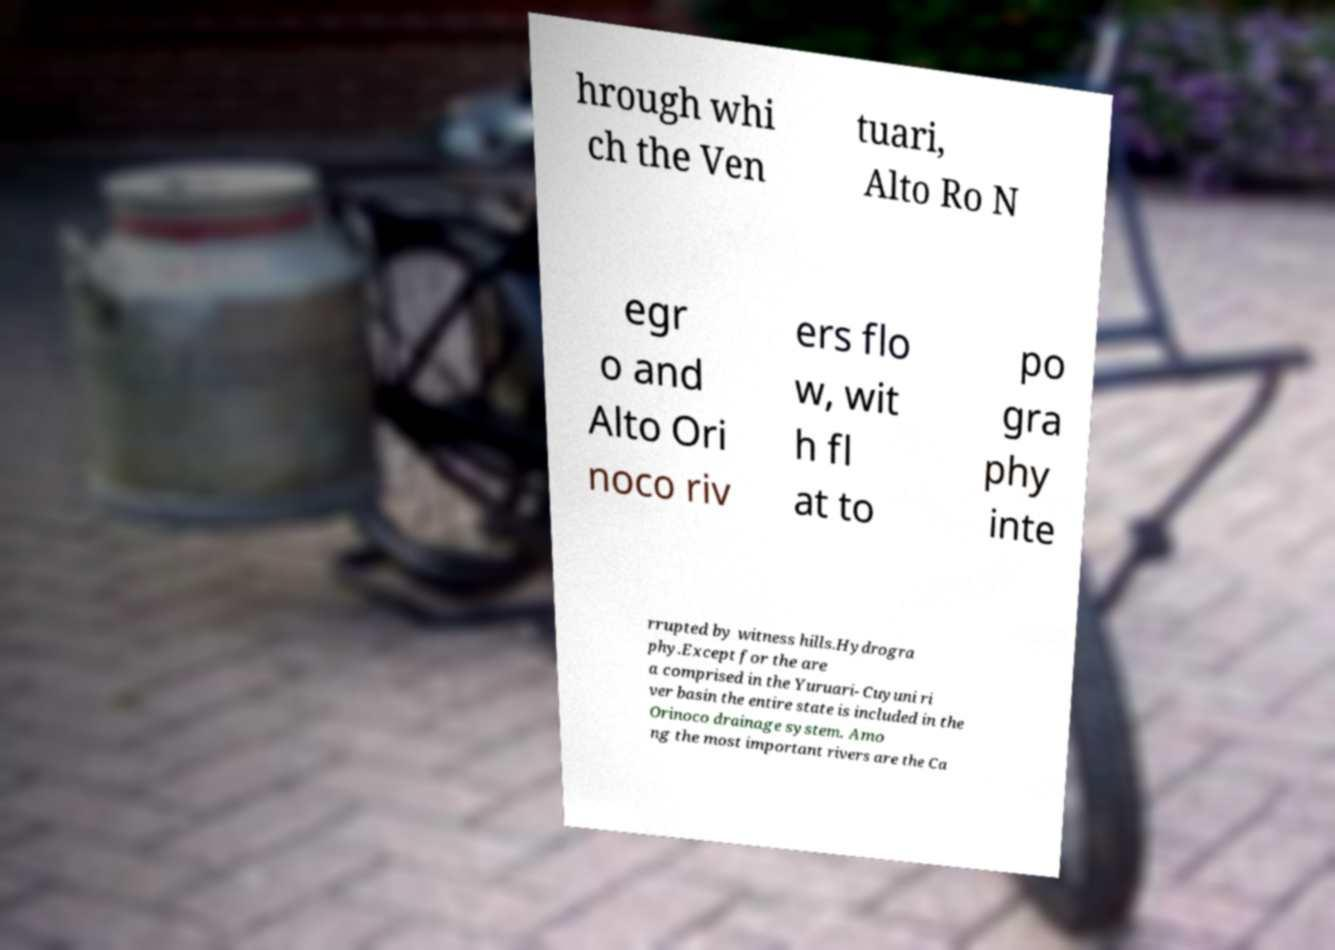I need the written content from this picture converted into text. Can you do that? hrough whi ch the Ven tuari, Alto Ro N egr o and Alto Ori noco riv ers flo w, wit h fl at to po gra phy inte rrupted by witness hills.Hydrogra phy.Except for the are a comprised in the Yuruari- Cuyuni ri ver basin the entire state is included in the Orinoco drainage system. Amo ng the most important rivers are the Ca 